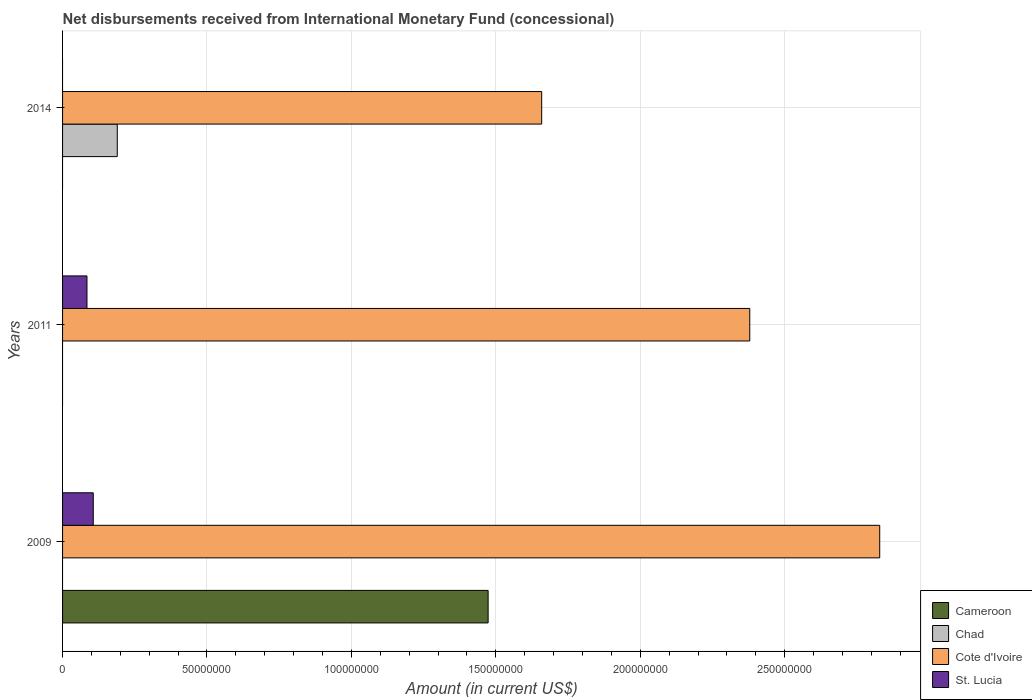How many different coloured bars are there?
Keep it short and to the point. 4. How many bars are there on the 1st tick from the top?
Provide a short and direct response. 2. How many bars are there on the 2nd tick from the bottom?
Provide a short and direct response. 2. What is the label of the 2nd group of bars from the top?
Provide a succinct answer. 2011. What is the amount of disbursements received from International Monetary Fund in Cote d'Ivoire in 2011?
Ensure brevity in your answer.  2.38e+08. Across all years, what is the maximum amount of disbursements received from International Monetary Fund in St. Lucia?
Provide a short and direct response. 1.06e+07. In which year was the amount of disbursements received from International Monetary Fund in Cote d'Ivoire maximum?
Provide a succinct answer. 2009. What is the total amount of disbursements received from International Monetary Fund in Cote d'Ivoire in the graph?
Provide a succinct answer. 6.87e+08. What is the difference between the amount of disbursements received from International Monetary Fund in Cote d'Ivoire in 2011 and that in 2014?
Make the answer very short. 7.20e+07. What is the difference between the amount of disbursements received from International Monetary Fund in Cote d'Ivoire in 2009 and the amount of disbursements received from International Monetary Fund in St. Lucia in 2014?
Your answer should be compact. 2.83e+08. What is the average amount of disbursements received from International Monetary Fund in Chad per year?
Offer a terse response. 6.32e+06. In the year 2009, what is the difference between the amount of disbursements received from International Monetary Fund in Cameroon and amount of disbursements received from International Monetary Fund in Cote d'Ivoire?
Make the answer very short. -1.36e+08. What is the ratio of the amount of disbursements received from International Monetary Fund in Cote d'Ivoire in 2009 to that in 2011?
Ensure brevity in your answer.  1.19. Is the amount of disbursements received from International Monetary Fund in Cote d'Ivoire in 2009 less than that in 2011?
Provide a succinct answer. No. What is the difference between the highest and the second highest amount of disbursements received from International Monetary Fund in Cote d'Ivoire?
Offer a terse response. 4.50e+07. What is the difference between the highest and the lowest amount of disbursements received from International Monetary Fund in Cote d'Ivoire?
Your answer should be very brief. 1.17e+08. In how many years, is the amount of disbursements received from International Monetary Fund in Cameroon greater than the average amount of disbursements received from International Monetary Fund in Cameroon taken over all years?
Your response must be concise. 1. How many bars are there?
Your response must be concise. 7. How many years are there in the graph?
Your response must be concise. 3. What is the difference between two consecutive major ticks on the X-axis?
Give a very brief answer. 5.00e+07. Are the values on the major ticks of X-axis written in scientific E-notation?
Give a very brief answer. No. Does the graph contain grids?
Your response must be concise. Yes. Where does the legend appear in the graph?
Provide a succinct answer. Bottom right. What is the title of the graph?
Keep it short and to the point. Net disbursements received from International Monetary Fund (concessional). What is the label or title of the Y-axis?
Provide a succinct answer. Years. What is the Amount (in current US$) of Cameroon in 2009?
Ensure brevity in your answer.  1.47e+08. What is the Amount (in current US$) in Chad in 2009?
Make the answer very short. 0. What is the Amount (in current US$) in Cote d'Ivoire in 2009?
Your answer should be compact. 2.83e+08. What is the Amount (in current US$) of St. Lucia in 2009?
Ensure brevity in your answer.  1.06e+07. What is the Amount (in current US$) in Cote d'Ivoire in 2011?
Make the answer very short. 2.38e+08. What is the Amount (in current US$) of St. Lucia in 2011?
Give a very brief answer. 8.45e+06. What is the Amount (in current US$) in Chad in 2014?
Give a very brief answer. 1.89e+07. What is the Amount (in current US$) of Cote d'Ivoire in 2014?
Ensure brevity in your answer.  1.66e+08. Across all years, what is the maximum Amount (in current US$) of Cameroon?
Make the answer very short. 1.47e+08. Across all years, what is the maximum Amount (in current US$) of Chad?
Offer a terse response. 1.89e+07. Across all years, what is the maximum Amount (in current US$) of Cote d'Ivoire?
Ensure brevity in your answer.  2.83e+08. Across all years, what is the maximum Amount (in current US$) in St. Lucia?
Keep it short and to the point. 1.06e+07. Across all years, what is the minimum Amount (in current US$) of Cameroon?
Your response must be concise. 0. Across all years, what is the minimum Amount (in current US$) in Cote d'Ivoire?
Provide a succinct answer. 1.66e+08. Across all years, what is the minimum Amount (in current US$) in St. Lucia?
Provide a succinct answer. 0. What is the total Amount (in current US$) in Cameroon in the graph?
Your answer should be compact. 1.47e+08. What is the total Amount (in current US$) of Chad in the graph?
Offer a terse response. 1.89e+07. What is the total Amount (in current US$) in Cote d'Ivoire in the graph?
Make the answer very short. 6.87e+08. What is the total Amount (in current US$) in St. Lucia in the graph?
Make the answer very short. 1.91e+07. What is the difference between the Amount (in current US$) of Cote d'Ivoire in 2009 and that in 2011?
Your answer should be compact. 4.50e+07. What is the difference between the Amount (in current US$) of St. Lucia in 2009 and that in 2011?
Provide a succinct answer. 2.18e+06. What is the difference between the Amount (in current US$) in Cote d'Ivoire in 2009 and that in 2014?
Keep it short and to the point. 1.17e+08. What is the difference between the Amount (in current US$) of Cote d'Ivoire in 2011 and that in 2014?
Give a very brief answer. 7.20e+07. What is the difference between the Amount (in current US$) of Cameroon in 2009 and the Amount (in current US$) of Cote d'Ivoire in 2011?
Your answer should be very brief. -9.06e+07. What is the difference between the Amount (in current US$) of Cameroon in 2009 and the Amount (in current US$) of St. Lucia in 2011?
Make the answer very short. 1.39e+08. What is the difference between the Amount (in current US$) of Cote d'Ivoire in 2009 and the Amount (in current US$) of St. Lucia in 2011?
Make the answer very short. 2.74e+08. What is the difference between the Amount (in current US$) in Cameroon in 2009 and the Amount (in current US$) in Chad in 2014?
Offer a terse response. 1.28e+08. What is the difference between the Amount (in current US$) of Cameroon in 2009 and the Amount (in current US$) of Cote d'Ivoire in 2014?
Keep it short and to the point. -1.85e+07. What is the average Amount (in current US$) of Cameroon per year?
Your answer should be compact. 4.91e+07. What is the average Amount (in current US$) in Chad per year?
Make the answer very short. 6.32e+06. What is the average Amount (in current US$) in Cote d'Ivoire per year?
Ensure brevity in your answer.  2.29e+08. What is the average Amount (in current US$) in St. Lucia per year?
Provide a short and direct response. 6.36e+06. In the year 2009, what is the difference between the Amount (in current US$) in Cameroon and Amount (in current US$) in Cote d'Ivoire?
Make the answer very short. -1.36e+08. In the year 2009, what is the difference between the Amount (in current US$) in Cameroon and Amount (in current US$) in St. Lucia?
Your answer should be compact. 1.37e+08. In the year 2009, what is the difference between the Amount (in current US$) of Cote d'Ivoire and Amount (in current US$) of St. Lucia?
Make the answer very short. 2.72e+08. In the year 2011, what is the difference between the Amount (in current US$) of Cote d'Ivoire and Amount (in current US$) of St. Lucia?
Provide a short and direct response. 2.29e+08. In the year 2014, what is the difference between the Amount (in current US$) in Chad and Amount (in current US$) in Cote d'Ivoire?
Your answer should be very brief. -1.47e+08. What is the ratio of the Amount (in current US$) of Cote d'Ivoire in 2009 to that in 2011?
Your response must be concise. 1.19. What is the ratio of the Amount (in current US$) of St. Lucia in 2009 to that in 2011?
Ensure brevity in your answer.  1.26. What is the ratio of the Amount (in current US$) of Cote d'Ivoire in 2009 to that in 2014?
Ensure brevity in your answer.  1.71. What is the ratio of the Amount (in current US$) in Cote d'Ivoire in 2011 to that in 2014?
Make the answer very short. 1.43. What is the difference between the highest and the second highest Amount (in current US$) of Cote d'Ivoire?
Ensure brevity in your answer.  4.50e+07. What is the difference between the highest and the lowest Amount (in current US$) in Cameroon?
Offer a very short reply. 1.47e+08. What is the difference between the highest and the lowest Amount (in current US$) of Chad?
Ensure brevity in your answer.  1.89e+07. What is the difference between the highest and the lowest Amount (in current US$) of Cote d'Ivoire?
Provide a succinct answer. 1.17e+08. What is the difference between the highest and the lowest Amount (in current US$) of St. Lucia?
Make the answer very short. 1.06e+07. 